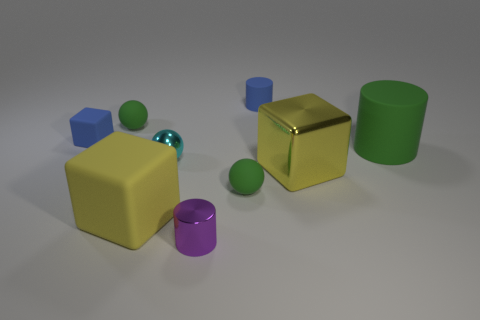Add 1 tiny rubber things. How many objects exist? 10 Subtract all cubes. How many objects are left? 6 Subtract all purple shiny cylinders. Subtract all yellow blocks. How many objects are left? 6 Add 8 yellow cubes. How many yellow cubes are left? 10 Add 2 green rubber spheres. How many green rubber spheres exist? 4 Subtract 0 yellow spheres. How many objects are left? 9 